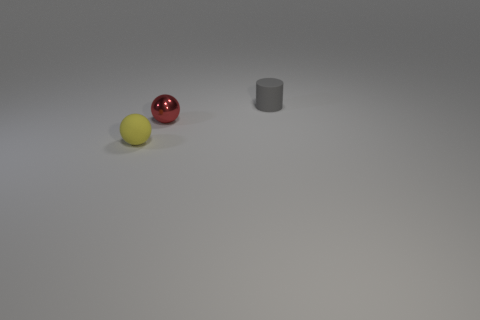What is the color of the tiny object that is right of the yellow rubber ball and in front of the tiny gray rubber thing?
Offer a very short reply. Red. How many other things are the same shape as the tiny gray thing?
Make the answer very short. 0. Is the number of tiny yellow rubber spheres behind the small cylinder less than the number of yellow matte balls to the right of the yellow rubber object?
Ensure brevity in your answer.  No. Do the tiny cylinder and the ball that is right of the yellow rubber sphere have the same material?
Provide a short and direct response. No. Is there any other thing that has the same material as the red ball?
Keep it short and to the point. No. Are there more tiny gray cylinders than large purple rubber cylinders?
Offer a very short reply. Yes. What shape is the tiny thing that is behind the small ball on the right side of the small matte thing in front of the gray cylinder?
Offer a terse response. Cylinder. Does the tiny sphere that is left of the red thing have the same material as the object on the right side of the red metallic object?
Give a very brief answer. Yes. The yellow object that is the same material as the gray cylinder is what shape?
Your answer should be very brief. Sphere. Is there anything else that is the same color as the small matte cylinder?
Offer a terse response. No. 